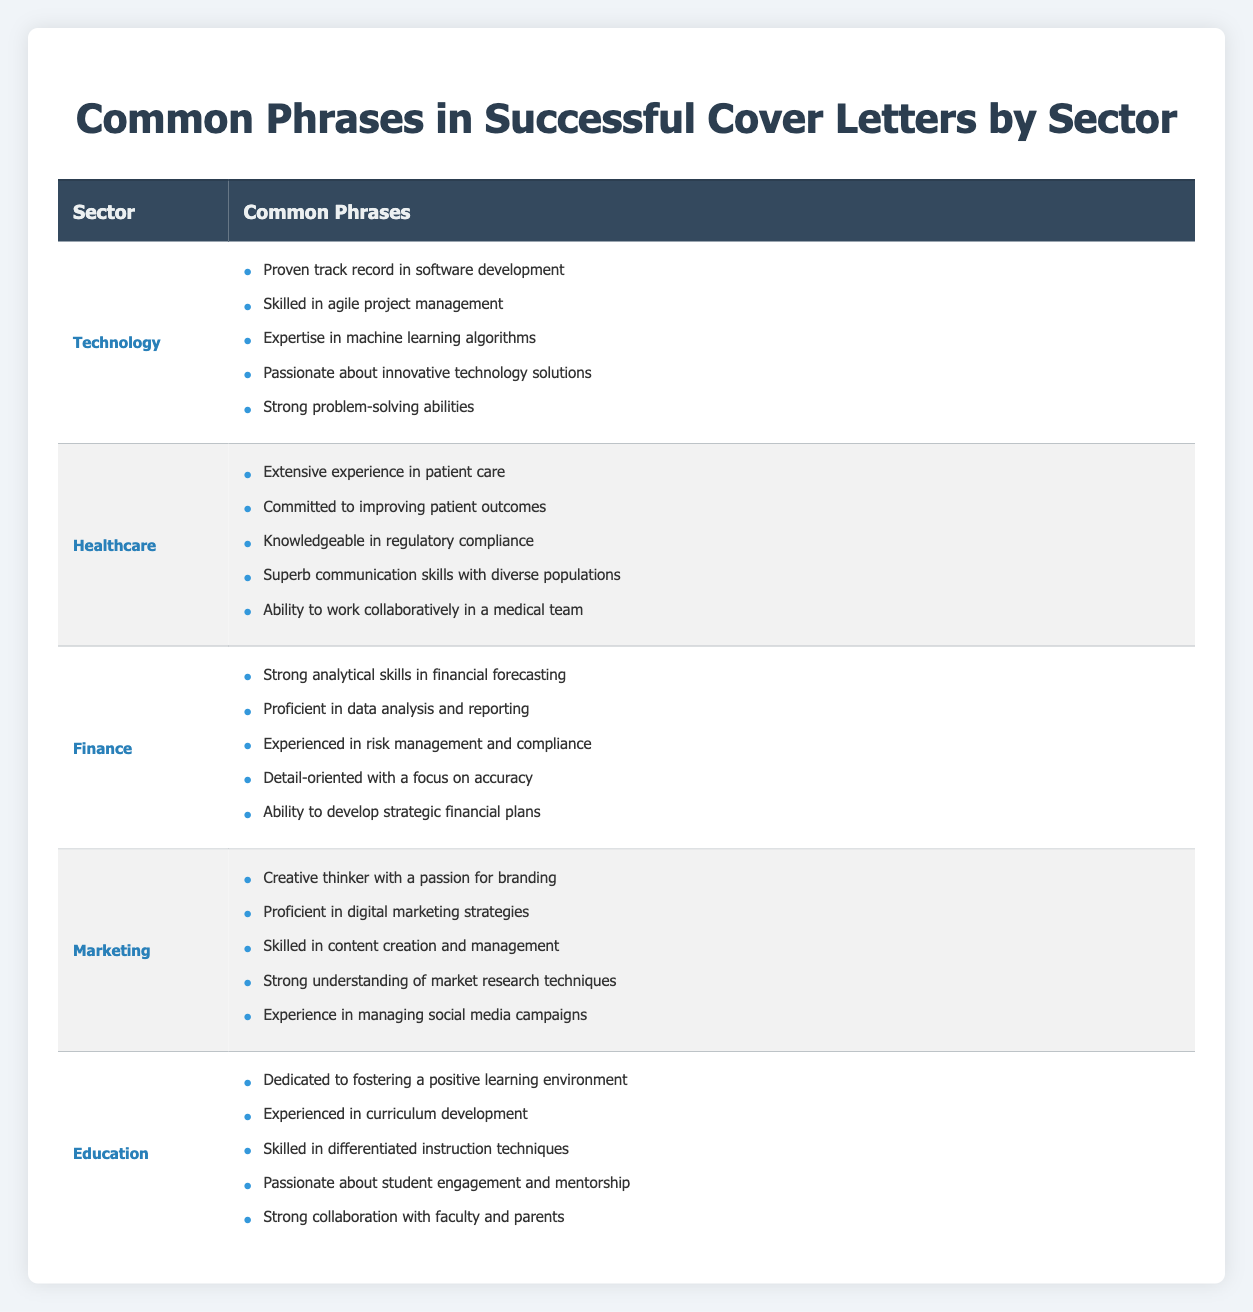What are the common phrases used in cover letters for the Marketing sector? The Marketing sector has the following common phrases: "Creative thinker with a passion for branding," "Proficient in digital marketing strategies," "Skilled in content creation and management," "Strong understanding of market research techniques," and "Experience in managing social media campaigns."
Answer: Marketing phrases listed Which sector includes a phrase about regulatory compliance? The Healthcare sector includes the phrase "Knowledgeable in regulatory compliance."
Answer: Healthcare Is "Strong problem-solving abilities" a phrase used in the Finance sector? No, "Strong problem-solving abilities" is not found in the Finance sector; it is used in the Technology sector instead.
Answer: No Which sector has the phrase "Dedicated to fostering a positive learning environment"? The sector with this phrase is Education, which emphasizes creating conducive learning spaces.
Answer: Education How many total unique phrases are listed in the Finance sector? There are 5 unique phrases in the Finance sector: "Strong analytical skills in financial forecasting," "Proficient in data analysis and reporting," "Experienced in risk management and compliance," "Detail-oriented with a focus on accuracy," and "Ability to develop strategic financial plans." So, the total is 5.
Answer: 5 Which sector has the most emphasis on teamwork characteristics in their common phrases? The Healthcare sector emphasizes teamwork with the phrase "Ability to work collaboratively in a medical team." This highlights the importance of collaboration in that field.
Answer: Healthcare Are there common phrases related to technology innovation in the Technology sector? Yes, the Technology sector includes the phrase "Passionate about innovative technology solutions," indicating a focus on technological advancement.
Answer: Yes What is the average number of common phrases per sector? There are 5 sectors, each with 5 phrases, totaling 25 phrases. Thus, the average is 25/5 = 5 phrases per sector.
Answer: 5 